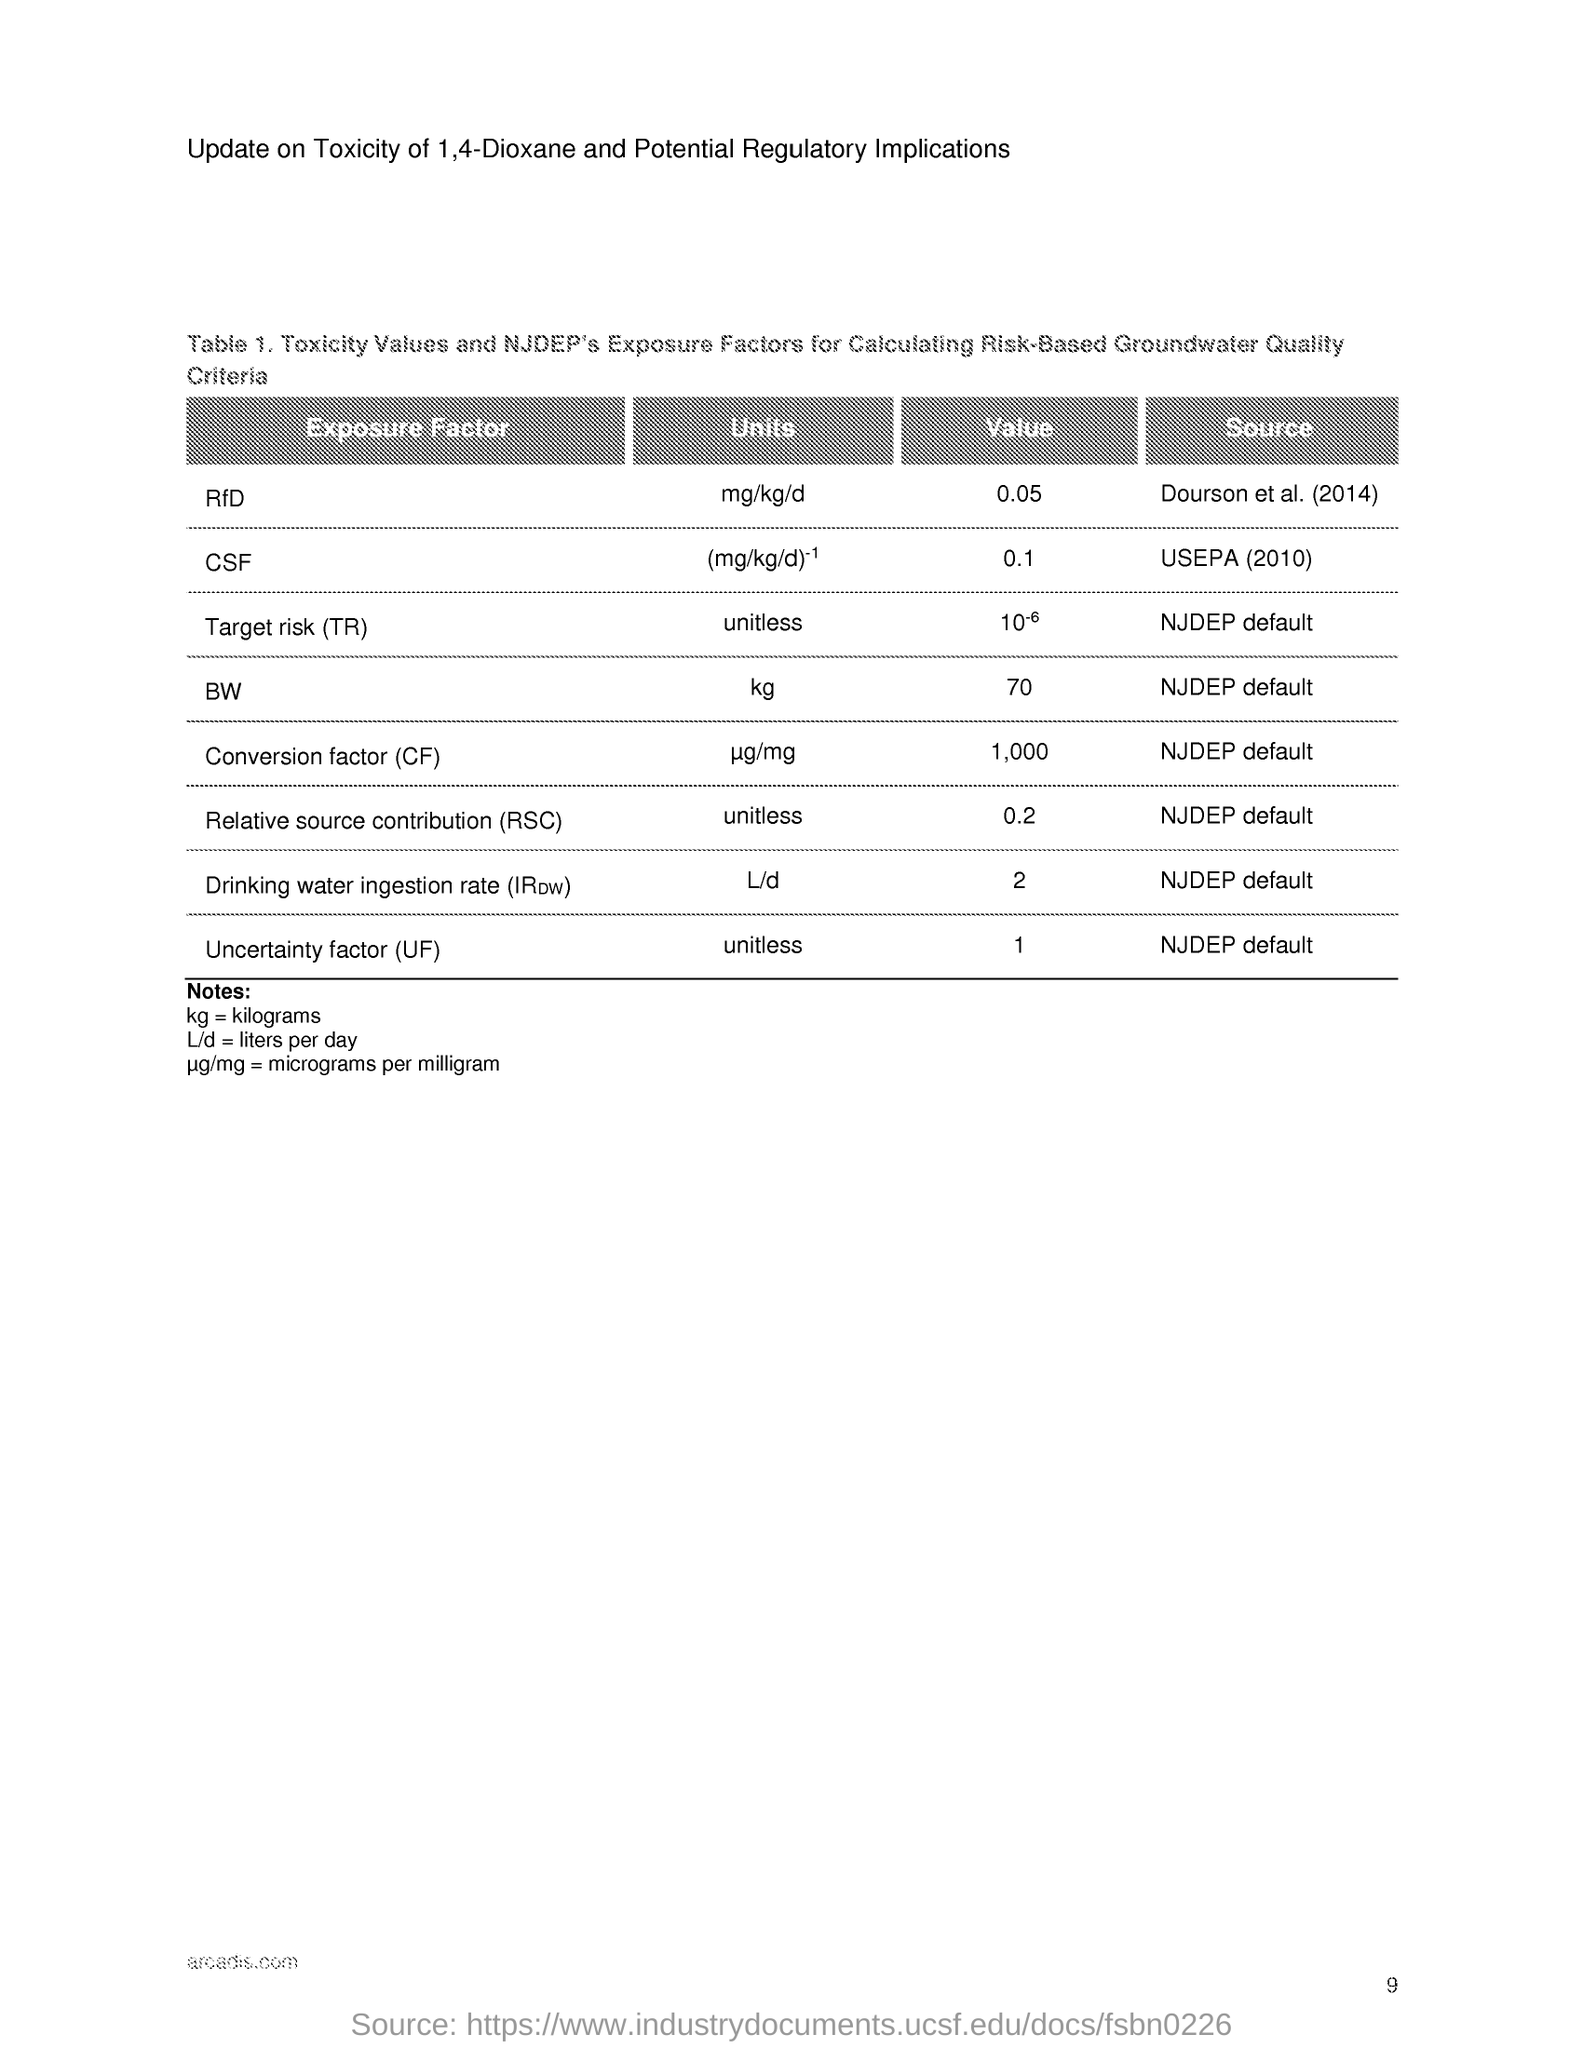Specify some key components in this picture. The unit of uncertainty factor is unitless, indicating that it represents a relative measure of the uncertainty in a measurement. What is referred to as kg is kilograms. The value of the conversion factor is 1,000. The units of BW, or body weight, are in kilograms. L/d is referred to as liters per day. 